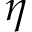Convert formula to latex. <formula><loc_0><loc_0><loc_500><loc_500>\eta</formula> 